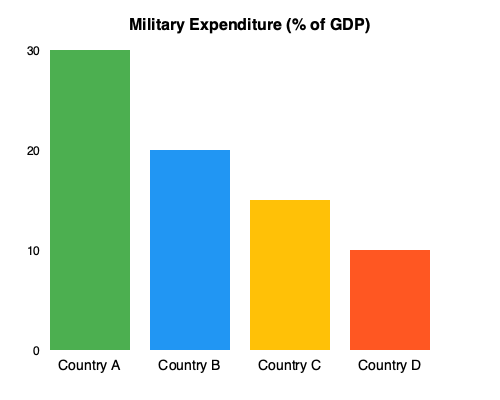Based on the bar chart showing military expenditure as a percentage of GDP for four conflict-affected countries, which country allocates the highest proportion of its GDP to military spending, and what implications might this have for its economic development and regional stability? To answer this question, we need to analyze the bar chart and consider the implications of high military spending in conflict-affected regions:

1. Interpret the chart:
   - The y-axis represents military expenditure as a percentage of GDP.
   - The x-axis shows four countries: A, B, C, and D.

2. Compare the bar heights:
   - Country A has the tallest bar, reaching about 30% of GDP.
   - Country B is second, at approximately 20% of GDP.
   - Country C is third, around 15% of GDP.
   - Country D has the shortest bar, at about 10% of GDP.

3. Identify the highest spender:
   - Country A allocates the highest proportion of its GDP to military spending.

4. Consider the implications:
   a) Economic development:
      - High military spending can divert resources from other crucial sectors like education, healthcare, and infrastructure.
      - This may hinder long-term economic growth and social development.

   b) Regional stability:
      - Excessive military spending might be perceived as aggressive by neighboring countries.
      - It could potentially escalate tensions and lead to an arms race in the region.
      - However, it might also serve as a deterrent against external threats.

   c) International relations:
      - High military expenditure might affect the country's relationships with international donors and investors.
      - It could impact foreign aid and economic cooperation agreements.

5. Contextual considerations:
   - The reasons behind high military spending (e.g., ongoing conflicts, geopolitical tensions) should be taken into account.
   - The absolute GDP value is not shown, so the actual monetary amount spent on military might vary among countries.

Given this analysis, an editor-in-chief covering political and economic developments in conflict zones would need to consider these factors when assigning stories and providing context for readers.
Answer: Country A; potential negative impact on economic development and regional stability due to resource allocation and perceived aggression. 